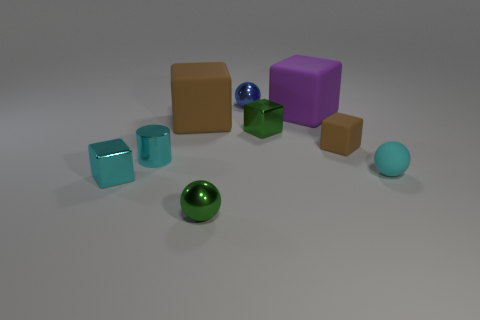Subtract all small cubes. How many cubes are left? 2 Subtract 1 spheres. How many spheres are left? 2 Subtract all purple spheres. How many brown cubes are left? 2 Subtract all brown cubes. How many cubes are left? 3 Add 1 tiny cyan matte spheres. How many objects exist? 10 Subtract all cubes. How many objects are left? 4 Subtract all yellow balls. Subtract all yellow cubes. How many balls are left? 3 Subtract all green spheres. Subtract all big brown cubes. How many objects are left? 7 Add 5 brown matte things. How many brown matte things are left? 7 Add 2 tiny blue objects. How many tiny blue objects exist? 3 